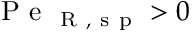<formula> <loc_0><loc_0><loc_500><loc_500>P e _ { R , s p } > 0</formula> 